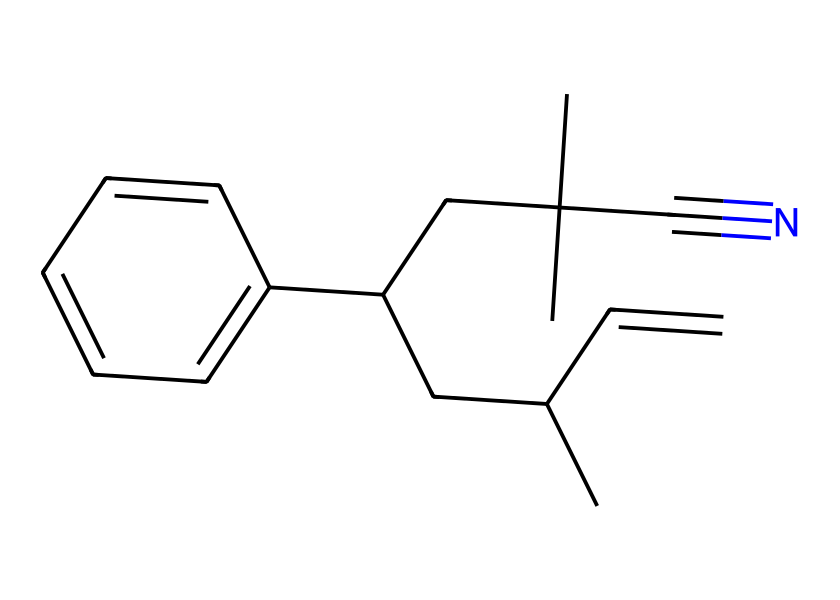What is the total number of carbon atoms in this compound? To find the total number of carbon atoms, we can analyze the SMILES notation. Each "C" represents a carbon atom. Counting all the carbon atoms in the structural representation gives a total of 16.
Answer: 16 How many double bonds are present in the chemical structure? In the chemical representation, a double bond is indicated by the "=" symbol. Examining the SMILES, we see there are two occurrences of the "=" sign, which indicates that there are two double bonds.
Answer: 2 What type of compound is this based on its properties? This compound does not contain ions or dissociate in solution, which characterizes it as a non-electrolyte. Thus, this compound is categorized as a non-electrolyte based on its structure.
Answer: non-electrolyte Which functional group is indicated by the "C#N" in the structure? The presence of "C#N" denotes a carbon triple-bonded to a nitrogen atom, indicating that this is a nitrile functional group. This is a distinctive functional group commonly found in organic compounds.
Answer: nitrile Is this compound likely to be soluble in water? Non-electrolytes are typically characterized by their lack of polarity and inability to ionize in solution. Since this particular compound is made up of many carbon atoms with limited polar functionality, it is likely to be insoluble in water.
Answer: insoluble What does the presence of multiple carbon branches suggest about the compound? The presence of multiple branched carbon chains in the compound suggests that it may have a complex three-dimensional shape, which can influence its physical properties like melting point and viscosity, making it a characteristic of many plastics.
Answer: complex shape 